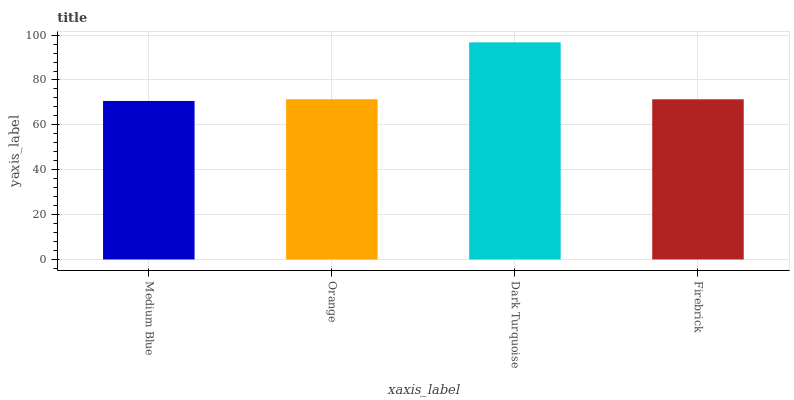Is Medium Blue the minimum?
Answer yes or no. Yes. Is Dark Turquoise the maximum?
Answer yes or no. Yes. Is Orange the minimum?
Answer yes or no. No. Is Orange the maximum?
Answer yes or no. No. Is Orange greater than Medium Blue?
Answer yes or no. Yes. Is Medium Blue less than Orange?
Answer yes or no. Yes. Is Medium Blue greater than Orange?
Answer yes or no. No. Is Orange less than Medium Blue?
Answer yes or no. No. Is Orange the high median?
Answer yes or no. Yes. Is Firebrick the low median?
Answer yes or no. Yes. Is Medium Blue the high median?
Answer yes or no. No. Is Orange the low median?
Answer yes or no. No. 